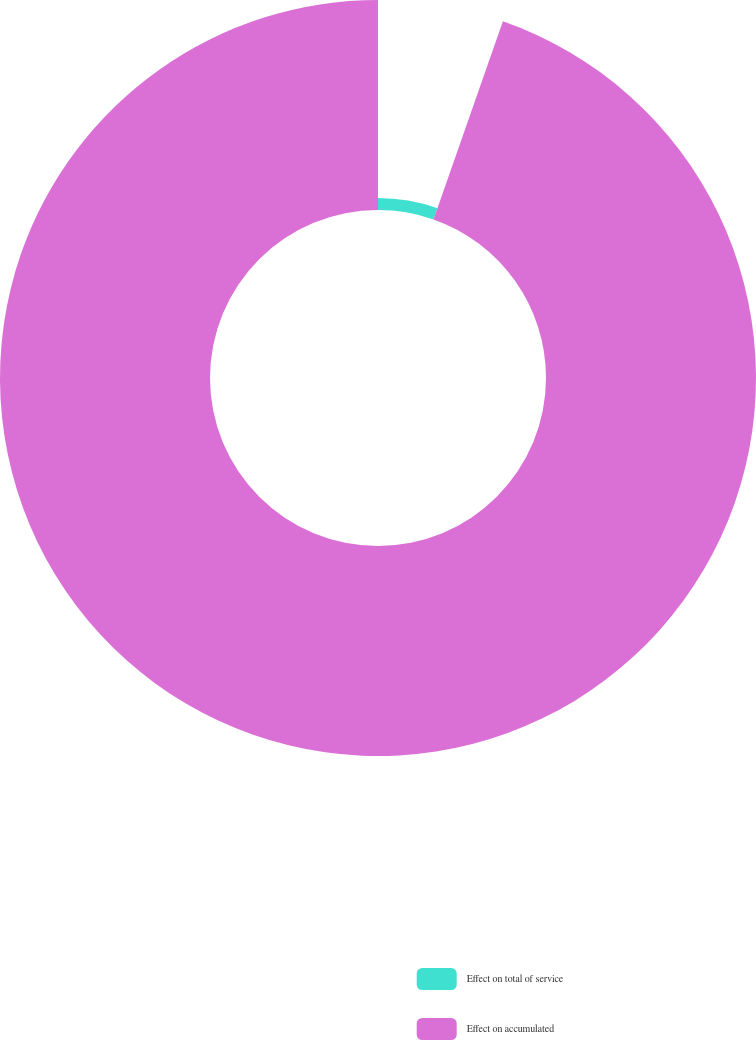Convert chart. <chart><loc_0><loc_0><loc_500><loc_500><pie_chart><fcel>Effect on total of service<fcel>Effect on accumulated<nl><fcel>5.36%<fcel>94.64%<nl></chart> 